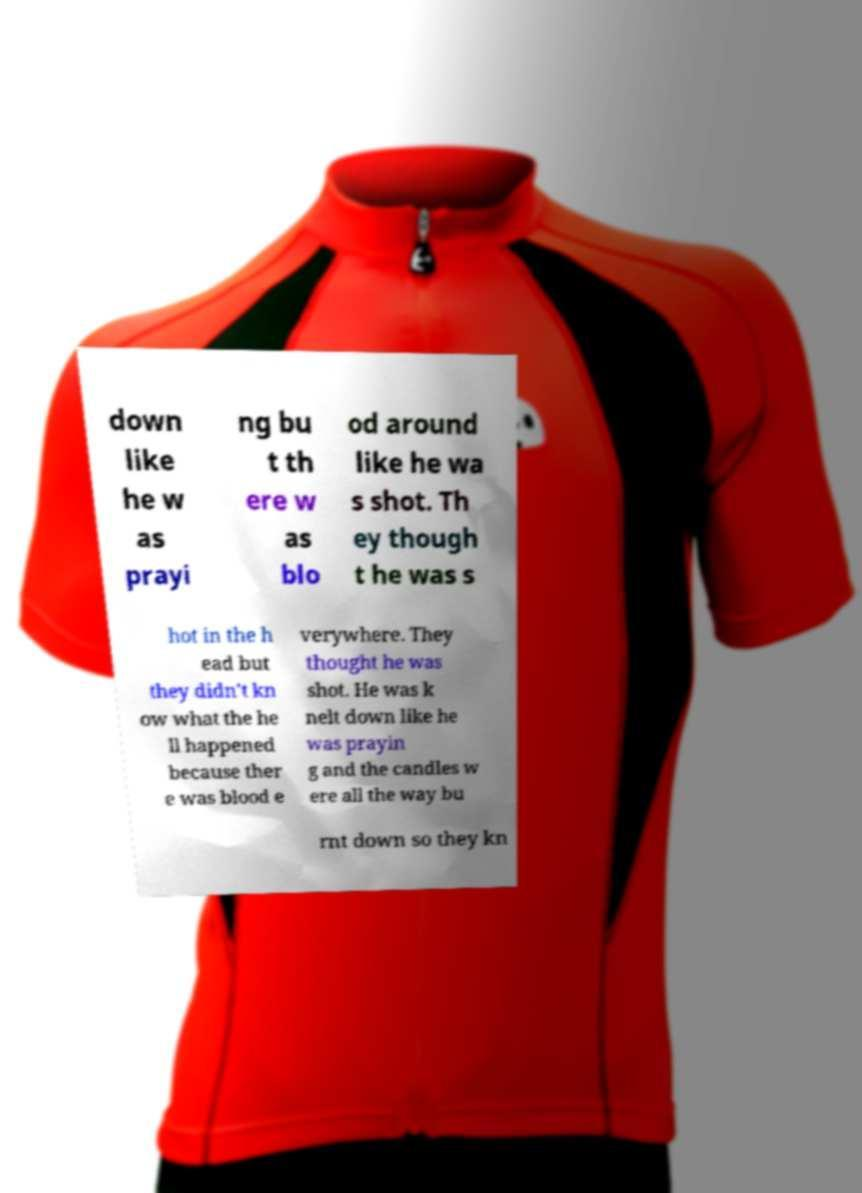Please identify and transcribe the text found in this image. down like he w as prayi ng bu t th ere w as blo od around like he wa s shot. Th ey though t he was s hot in the h ead but they didn't kn ow what the he ll happened because ther e was blood e verywhere. They thought he was shot. He was k nelt down like he was prayin g and the candles w ere all the way bu rnt down so they kn 